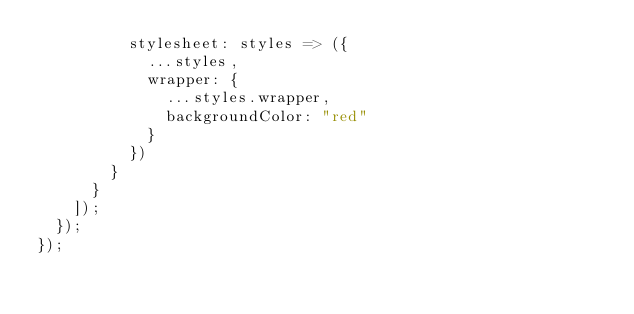<code> <loc_0><loc_0><loc_500><loc_500><_JavaScript_>          stylesheet: styles => ({
            ...styles,
            wrapper: {
              ...styles.wrapper,
              backgroundColor: "red"
            }
          })
        }
      }
    ]);
  });
});
</code> 